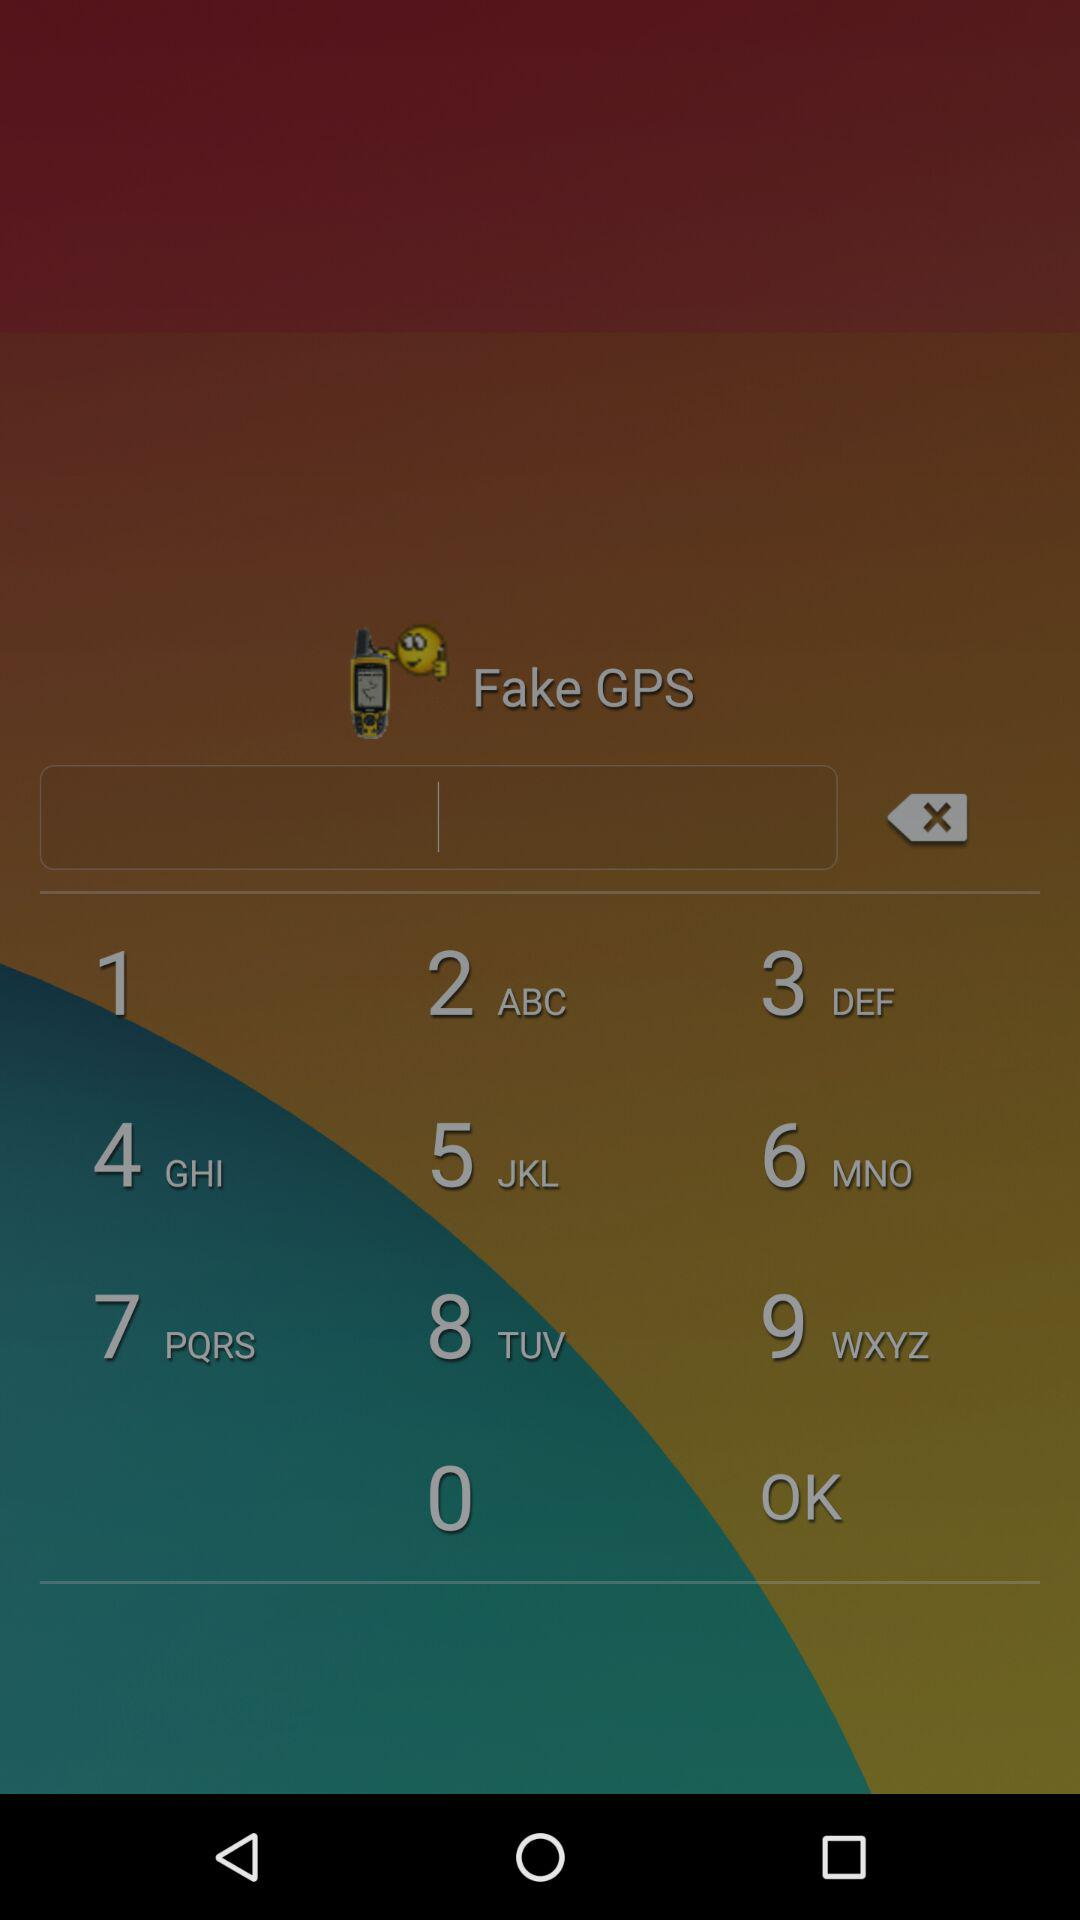What is the phone number of Sam? The phone number of Sam is (847)364-7901. 